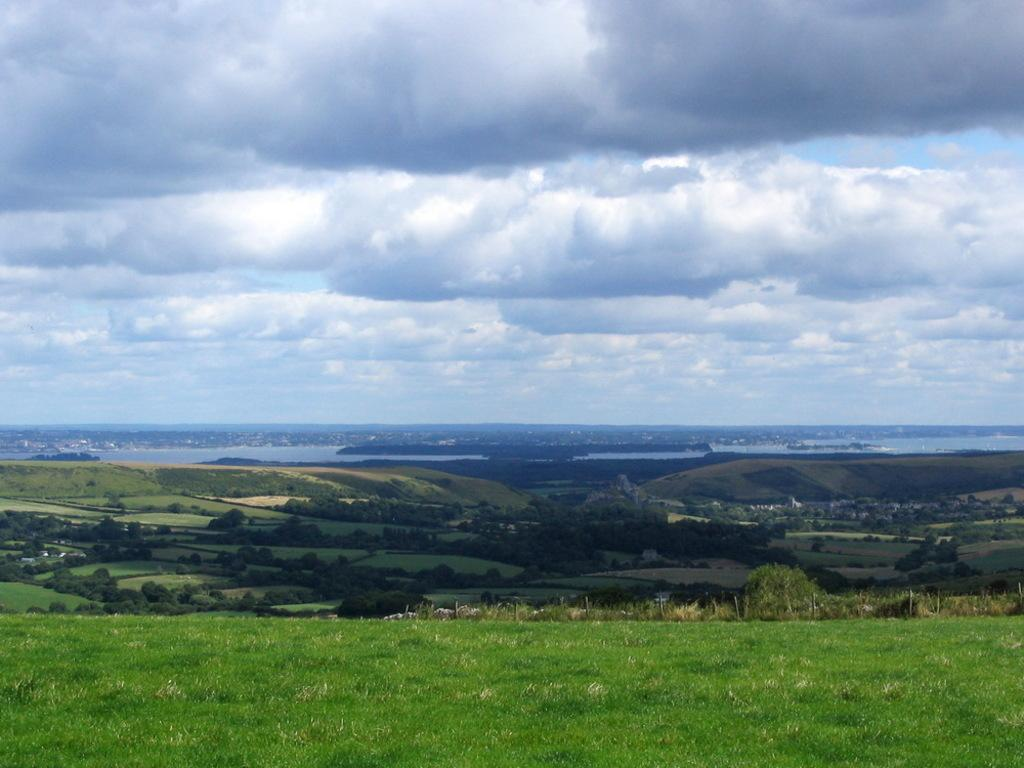What type of vegetation can be seen in the image? There are trees in the image. What natural element is visible in the image besides trees? There is water visible in the image. What is visible in the sky in the image? The sky is visible in the image, and clouds are present. What type of ground surface is at the bottom of the image? There is grass at the bottom of the image. What type of acoustics can be heard in the image? There is no sound or acoustics present in the image, as it is a still picture. 